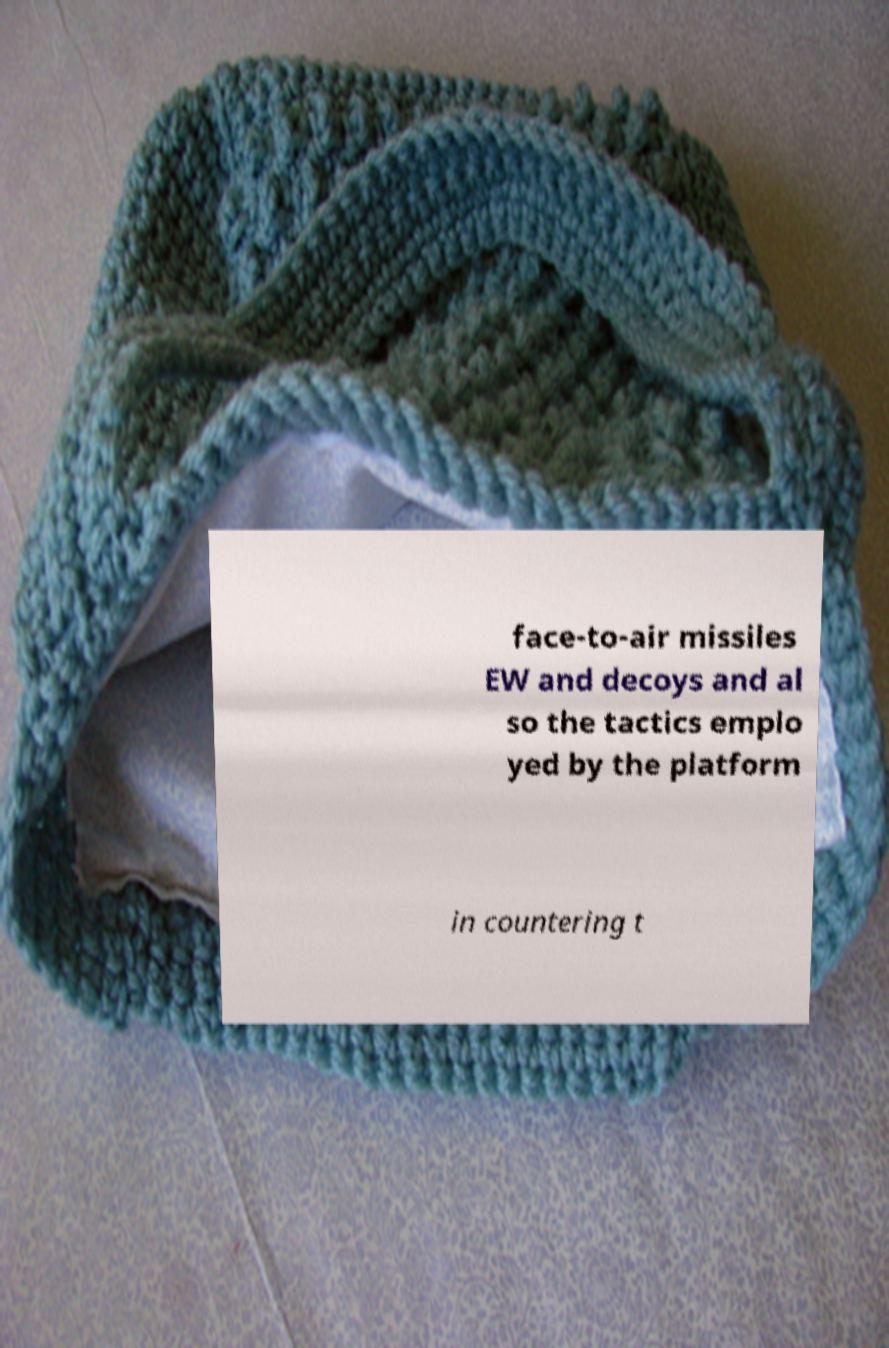Can you accurately transcribe the text from the provided image for me? face-to-air missiles EW and decoys and al so the tactics emplo yed by the platform in countering t 